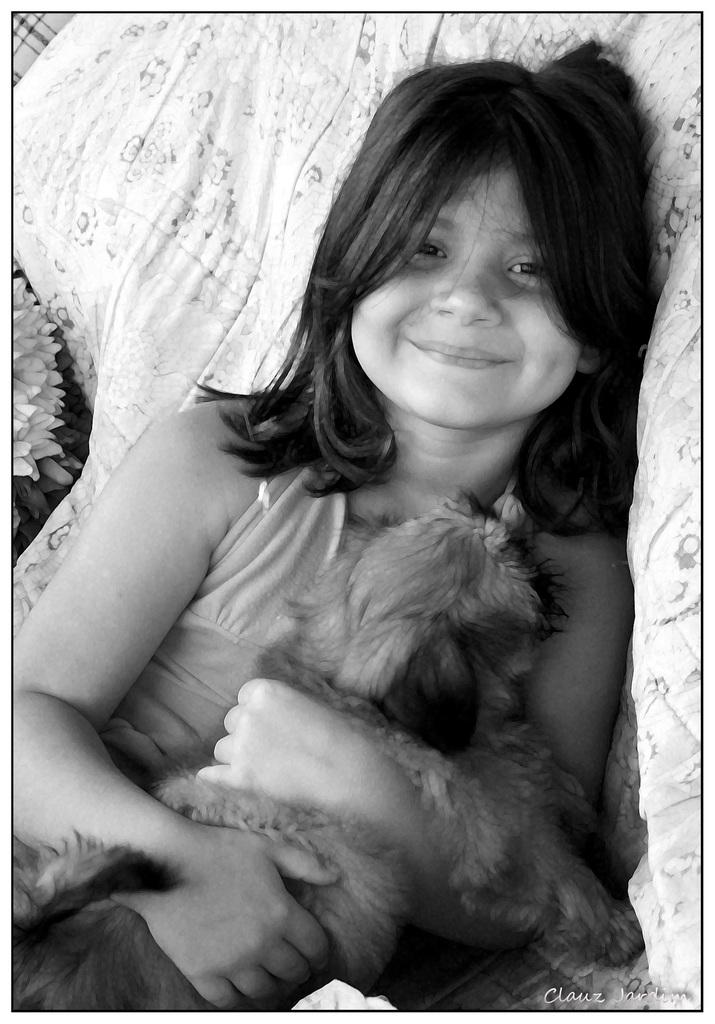Who is present in the image? There is a girl in the image. What is the girl holding in the image? The girl is holding an animal in the image. Where is the animal located in the image? The animal is lying on a bed in the image. What type of canvas is the girl using to balance the animal in the image? There is no canvas present in the image, and the girl is not using any canvas to balance the animal. 